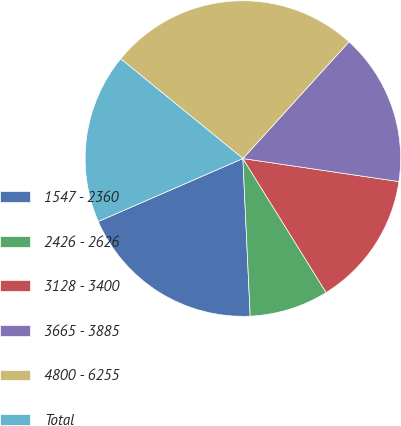Convert chart to OTSL. <chart><loc_0><loc_0><loc_500><loc_500><pie_chart><fcel>1547 - 2360<fcel>2426 - 2626<fcel>3128 - 3400<fcel>3665 - 3885<fcel>4800 - 6255<fcel>Total<nl><fcel>19.2%<fcel>8.11%<fcel>13.82%<fcel>15.59%<fcel>25.84%<fcel>17.43%<nl></chart> 